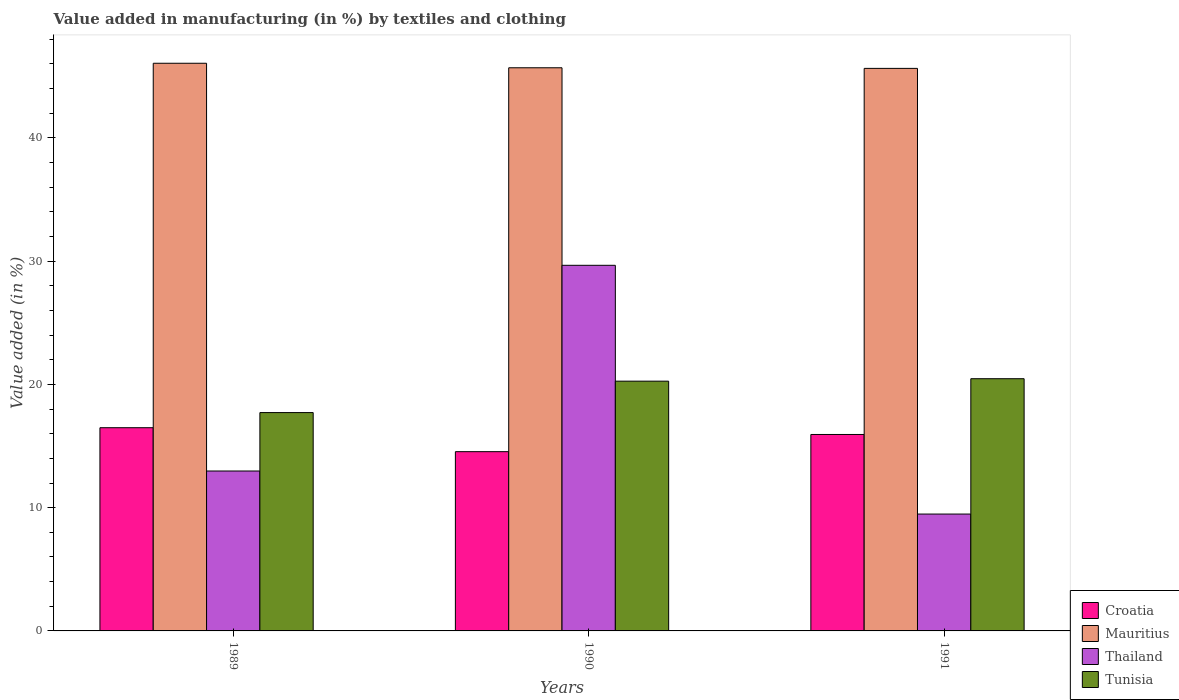How many different coloured bars are there?
Ensure brevity in your answer.  4. How many bars are there on the 1st tick from the left?
Ensure brevity in your answer.  4. How many bars are there on the 1st tick from the right?
Ensure brevity in your answer.  4. What is the percentage of value added in manufacturing by textiles and clothing in Croatia in 1990?
Ensure brevity in your answer.  14.54. Across all years, what is the maximum percentage of value added in manufacturing by textiles and clothing in Tunisia?
Keep it short and to the point. 20.46. Across all years, what is the minimum percentage of value added in manufacturing by textiles and clothing in Mauritius?
Your answer should be compact. 45.64. In which year was the percentage of value added in manufacturing by textiles and clothing in Mauritius maximum?
Offer a very short reply. 1989. In which year was the percentage of value added in manufacturing by textiles and clothing in Croatia minimum?
Your response must be concise. 1990. What is the total percentage of value added in manufacturing by textiles and clothing in Croatia in the graph?
Your answer should be very brief. 46.97. What is the difference between the percentage of value added in manufacturing by textiles and clothing in Thailand in 1989 and that in 1990?
Keep it short and to the point. -16.69. What is the difference between the percentage of value added in manufacturing by textiles and clothing in Tunisia in 1989 and the percentage of value added in manufacturing by textiles and clothing in Mauritius in 1991?
Provide a short and direct response. -27.93. What is the average percentage of value added in manufacturing by textiles and clothing in Mauritius per year?
Provide a succinct answer. 45.8. In the year 1991, what is the difference between the percentage of value added in manufacturing by textiles and clothing in Thailand and percentage of value added in manufacturing by textiles and clothing in Mauritius?
Your answer should be compact. -36.16. What is the ratio of the percentage of value added in manufacturing by textiles and clothing in Thailand in 1989 to that in 1990?
Keep it short and to the point. 0.44. Is the percentage of value added in manufacturing by textiles and clothing in Croatia in 1989 less than that in 1990?
Make the answer very short. No. Is the difference between the percentage of value added in manufacturing by textiles and clothing in Thailand in 1989 and 1991 greater than the difference between the percentage of value added in manufacturing by textiles and clothing in Mauritius in 1989 and 1991?
Provide a short and direct response. Yes. What is the difference between the highest and the second highest percentage of value added in manufacturing by textiles and clothing in Tunisia?
Provide a short and direct response. 0.2. What is the difference between the highest and the lowest percentage of value added in manufacturing by textiles and clothing in Tunisia?
Provide a short and direct response. 2.75. Is the sum of the percentage of value added in manufacturing by textiles and clothing in Croatia in 1990 and 1991 greater than the maximum percentage of value added in manufacturing by textiles and clothing in Thailand across all years?
Keep it short and to the point. Yes. What does the 4th bar from the left in 1989 represents?
Keep it short and to the point. Tunisia. What does the 3rd bar from the right in 1989 represents?
Offer a terse response. Mauritius. What is the difference between two consecutive major ticks on the Y-axis?
Your response must be concise. 10. Are the values on the major ticks of Y-axis written in scientific E-notation?
Ensure brevity in your answer.  No. Does the graph contain grids?
Keep it short and to the point. No. What is the title of the graph?
Provide a short and direct response. Value added in manufacturing (in %) by textiles and clothing. What is the label or title of the Y-axis?
Keep it short and to the point. Value added (in %). What is the Value added (in %) of Croatia in 1989?
Provide a short and direct response. 16.49. What is the Value added (in %) in Mauritius in 1989?
Your response must be concise. 46.06. What is the Value added (in %) of Thailand in 1989?
Offer a terse response. 12.97. What is the Value added (in %) in Tunisia in 1989?
Make the answer very short. 17.71. What is the Value added (in %) of Croatia in 1990?
Your response must be concise. 14.54. What is the Value added (in %) of Mauritius in 1990?
Provide a succinct answer. 45.69. What is the Value added (in %) in Thailand in 1990?
Your response must be concise. 29.66. What is the Value added (in %) in Tunisia in 1990?
Provide a succinct answer. 20.26. What is the Value added (in %) of Croatia in 1991?
Give a very brief answer. 15.94. What is the Value added (in %) in Mauritius in 1991?
Provide a succinct answer. 45.64. What is the Value added (in %) of Thailand in 1991?
Your answer should be compact. 9.48. What is the Value added (in %) in Tunisia in 1991?
Give a very brief answer. 20.46. Across all years, what is the maximum Value added (in %) in Croatia?
Make the answer very short. 16.49. Across all years, what is the maximum Value added (in %) in Mauritius?
Make the answer very short. 46.06. Across all years, what is the maximum Value added (in %) of Thailand?
Provide a short and direct response. 29.66. Across all years, what is the maximum Value added (in %) of Tunisia?
Make the answer very short. 20.46. Across all years, what is the minimum Value added (in %) of Croatia?
Your answer should be compact. 14.54. Across all years, what is the minimum Value added (in %) in Mauritius?
Provide a short and direct response. 45.64. Across all years, what is the minimum Value added (in %) in Thailand?
Make the answer very short. 9.48. Across all years, what is the minimum Value added (in %) in Tunisia?
Offer a terse response. 17.71. What is the total Value added (in %) in Croatia in the graph?
Offer a very short reply. 46.97. What is the total Value added (in %) of Mauritius in the graph?
Offer a very short reply. 137.39. What is the total Value added (in %) in Thailand in the graph?
Your response must be concise. 52.12. What is the total Value added (in %) of Tunisia in the graph?
Make the answer very short. 58.44. What is the difference between the Value added (in %) in Croatia in 1989 and that in 1990?
Keep it short and to the point. 1.94. What is the difference between the Value added (in %) in Mauritius in 1989 and that in 1990?
Offer a terse response. 0.37. What is the difference between the Value added (in %) of Thailand in 1989 and that in 1990?
Your answer should be compact. -16.69. What is the difference between the Value added (in %) in Tunisia in 1989 and that in 1990?
Your answer should be compact. -2.55. What is the difference between the Value added (in %) of Croatia in 1989 and that in 1991?
Ensure brevity in your answer.  0.55. What is the difference between the Value added (in %) of Mauritius in 1989 and that in 1991?
Give a very brief answer. 0.42. What is the difference between the Value added (in %) of Thailand in 1989 and that in 1991?
Ensure brevity in your answer.  3.49. What is the difference between the Value added (in %) in Tunisia in 1989 and that in 1991?
Your response must be concise. -2.75. What is the difference between the Value added (in %) of Croatia in 1990 and that in 1991?
Your answer should be compact. -1.39. What is the difference between the Value added (in %) in Mauritius in 1990 and that in 1991?
Ensure brevity in your answer.  0.05. What is the difference between the Value added (in %) in Thailand in 1990 and that in 1991?
Offer a terse response. 20.18. What is the difference between the Value added (in %) of Tunisia in 1990 and that in 1991?
Keep it short and to the point. -0.2. What is the difference between the Value added (in %) of Croatia in 1989 and the Value added (in %) of Mauritius in 1990?
Give a very brief answer. -29.2. What is the difference between the Value added (in %) in Croatia in 1989 and the Value added (in %) in Thailand in 1990?
Offer a terse response. -13.18. What is the difference between the Value added (in %) in Croatia in 1989 and the Value added (in %) in Tunisia in 1990?
Your answer should be compact. -3.78. What is the difference between the Value added (in %) of Mauritius in 1989 and the Value added (in %) of Thailand in 1990?
Your response must be concise. 16.39. What is the difference between the Value added (in %) in Mauritius in 1989 and the Value added (in %) in Tunisia in 1990?
Make the answer very short. 25.79. What is the difference between the Value added (in %) in Thailand in 1989 and the Value added (in %) in Tunisia in 1990?
Give a very brief answer. -7.29. What is the difference between the Value added (in %) of Croatia in 1989 and the Value added (in %) of Mauritius in 1991?
Provide a succinct answer. -29.15. What is the difference between the Value added (in %) in Croatia in 1989 and the Value added (in %) in Thailand in 1991?
Provide a succinct answer. 7.01. What is the difference between the Value added (in %) of Croatia in 1989 and the Value added (in %) of Tunisia in 1991?
Your response must be concise. -3.97. What is the difference between the Value added (in %) of Mauritius in 1989 and the Value added (in %) of Thailand in 1991?
Keep it short and to the point. 36.57. What is the difference between the Value added (in %) of Mauritius in 1989 and the Value added (in %) of Tunisia in 1991?
Keep it short and to the point. 25.59. What is the difference between the Value added (in %) of Thailand in 1989 and the Value added (in %) of Tunisia in 1991?
Keep it short and to the point. -7.49. What is the difference between the Value added (in %) of Croatia in 1990 and the Value added (in %) of Mauritius in 1991?
Keep it short and to the point. -31.1. What is the difference between the Value added (in %) in Croatia in 1990 and the Value added (in %) in Thailand in 1991?
Offer a terse response. 5.06. What is the difference between the Value added (in %) of Croatia in 1990 and the Value added (in %) of Tunisia in 1991?
Ensure brevity in your answer.  -5.92. What is the difference between the Value added (in %) in Mauritius in 1990 and the Value added (in %) in Thailand in 1991?
Your answer should be very brief. 36.21. What is the difference between the Value added (in %) in Mauritius in 1990 and the Value added (in %) in Tunisia in 1991?
Provide a short and direct response. 25.23. What is the difference between the Value added (in %) of Thailand in 1990 and the Value added (in %) of Tunisia in 1991?
Provide a succinct answer. 9.2. What is the average Value added (in %) in Croatia per year?
Ensure brevity in your answer.  15.66. What is the average Value added (in %) in Mauritius per year?
Your response must be concise. 45.8. What is the average Value added (in %) of Thailand per year?
Ensure brevity in your answer.  17.37. What is the average Value added (in %) in Tunisia per year?
Give a very brief answer. 19.48. In the year 1989, what is the difference between the Value added (in %) of Croatia and Value added (in %) of Mauritius?
Offer a very short reply. -29.57. In the year 1989, what is the difference between the Value added (in %) in Croatia and Value added (in %) in Thailand?
Your response must be concise. 3.51. In the year 1989, what is the difference between the Value added (in %) of Croatia and Value added (in %) of Tunisia?
Offer a very short reply. -1.23. In the year 1989, what is the difference between the Value added (in %) in Mauritius and Value added (in %) in Thailand?
Ensure brevity in your answer.  33.08. In the year 1989, what is the difference between the Value added (in %) in Mauritius and Value added (in %) in Tunisia?
Ensure brevity in your answer.  28.34. In the year 1989, what is the difference between the Value added (in %) of Thailand and Value added (in %) of Tunisia?
Provide a short and direct response. -4.74. In the year 1990, what is the difference between the Value added (in %) in Croatia and Value added (in %) in Mauritius?
Ensure brevity in your answer.  -31.15. In the year 1990, what is the difference between the Value added (in %) of Croatia and Value added (in %) of Thailand?
Make the answer very short. -15.12. In the year 1990, what is the difference between the Value added (in %) of Croatia and Value added (in %) of Tunisia?
Your answer should be very brief. -5.72. In the year 1990, what is the difference between the Value added (in %) in Mauritius and Value added (in %) in Thailand?
Ensure brevity in your answer.  16.03. In the year 1990, what is the difference between the Value added (in %) in Mauritius and Value added (in %) in Tunisia?
Provide a succinct answer. 25.43. In the year 1990, what is the difference between the Value added (in %) of Thailand and Value added (in %) of Tunisia?
Give a very brief answer. 9.4. In the year 1991, what is the difference between the Value added (in %) of Croatia and Value added (in %) of Mauritius?
Provide a succinct answer. -29.7. In the year 1991, what is the difference between the Value added (in %) in Croatia and Value added (in %) in Thailand?
Keep it short and to the point. 6.46. In the year 1991, what is the difference between the Value added (in %) of Croatia and Value added (in %) of Tunisia?
Give a very brief answer. -4.52. In the year 1991, what is the difference between the Value added (in %) in Mauritius and Value added (in %) in Thailand?
Provide a succinct answer. 36.16. In the year 1991, what is the difference between the Value added (in %) of Mauritius and Value added (in %) of Tunisia?
Your response must be concise. 25.18. In the year 1991, what is the difference between the Value added (in %) in Thailand and Value added (in %) in Tunisia?
Offer a very short reply. -10.98. What is the ratio of the Value added (in %) of Croatia in 1989 to that in 1990?
Offer a terse response. 1.13. What is the ratio of the Value added (in %) of Mauritius in 1989 to that in 1990?
Your answer should be very brief. 1.01. What is the ratio of the Value added (in %) in Thailand in 1989 to that in 1990?
Provide a short and direct response. 0.44. What is the ratio of the Value added (in %) of Tunisia in 1989 to that in 1990?
Your answer should be compact. 0.87. What is the ratio of the Value added (in %) in Croatia in 1989 to that in 1991?
Keep it short and to the point. 1.03. What is the ratio of the Value added (in %) of Mauritius in 1989 to that in 1991?
Your response must be concise. 1.01. What is the ratio of the Value added (in %) of Thailand in 1989 to that in 1991?
Provide a short and direct response. 1.37. What is the ratio of the Value added (in %) in Tunisia in 1989 to that in 1991?
Make the answer very short. 0.87. What is the ratio of the Value added (in %) of Croatia in 1990 to that in 1991?
Provide a short and direct response. 0.91. What is the ratio of the Value added (in %) of Mauritius in 1990 to that in 1991?
Your response must be concise. 1. What is the ratio of the Value added (in %) in Thailand in 1990 to that in 1991?
Provide a short and direct response. 3.13. What is the ratio of the Value added (in %) in Tunisia in 1990 to that in 1991?
Provide a short and direct response. 0.99. What is the difference between the highest and the second highest Value added (in %) of Croatia?
Keep it short and to the point. 0.55. What is the difference between the highest and the second highest Value added (in %) of Mauritius?
Your answer should be compact. 0.37. What is the difference between the highest and the second highest Value added (in %) of Thailand?
Your response must be concise. 16.69. What is the difference between the highest and the second highest Value added (in %) of Tunisia?
Ensure brevity in your answer.  0.2. What is the difference between the highest and the lowest Value added (in %) of Croatia?
Keep it short and to the point. 1.94. What is the difference between the highest and the lowest Value added (in %) of Mauritius?
Your response must be concise. 0.42. What is the difference between the highest and the lowest Value added (in %) of Thailand?
Ensure brevity in your answer.  20.18. What is the difference between the highest and the lowest Value added (in %) in Tunisia?
Your answer should be compact. 2.75. 